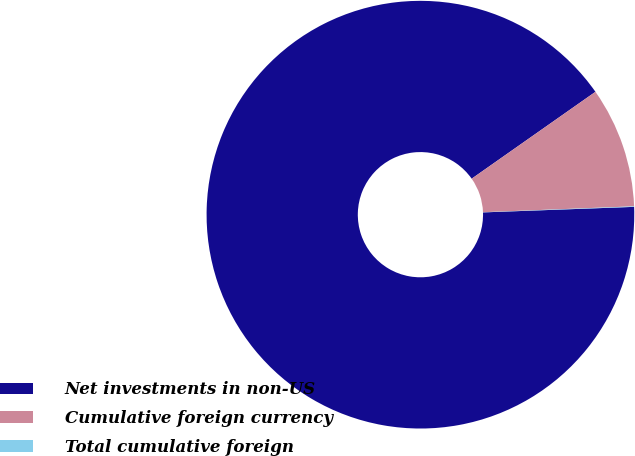Convert chart. <chart><loc_0><loc_0><loc_500><loc_500><pie_chart><fcel>Net investments in non-US<fcel>Cumulative foreign currency<fcel>Total cumulative foreign<nl><fcel>90.85%<fcel>9.12%<fcel>0.04%<nl></chart> 